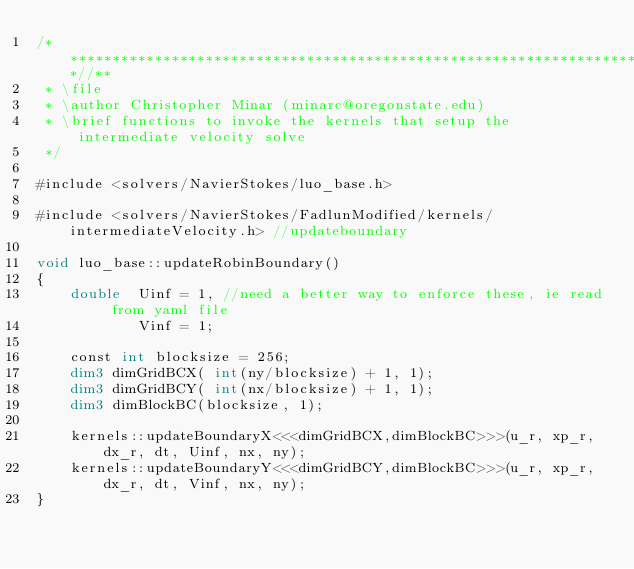Convert code to text. <code><loc_0><loc_0><loc_500><loc_500><_Cuda_>/***************************************************************************//**
 * \file
 * \author Christopher Minar (minarc@oregonstate.edu)
 * \brief functions to invoke the kernels that setup the intermediate velocity solve
 */

#include <solvers/NavierStokes/luo_base.h>

#include <solvers/NavierStokes/FadlunModified/kernels/intermediateVelocity.h> //updateboundary

void luo_base::updateRobinBoundary()
{
	double 	Uinf = 1, //need a better way to enforce these, ie read from yaml file
			Vinf = 1;

	const int blocksize = 256;
	dim3 dimGridBCX( int(ny/blocksize) + 1, 1);
	dim3 dimGridBCY( int(nx/blocksize) + 1, 1);
	dim3 dimBlockBC(blocksize, 1);

	kernels::updateBoundaryX<<<dimGridBCX,dimBlockBC>>>(u_r, xp_r, dx_r, dt, Uinf, nx, ny);
	kernels::updateBoundaryY<<<dimGridBCY,dimBlockBC>>>(u_r, xp_r, dx_r, dt, Vinf, nx, ny);
}
</code> 